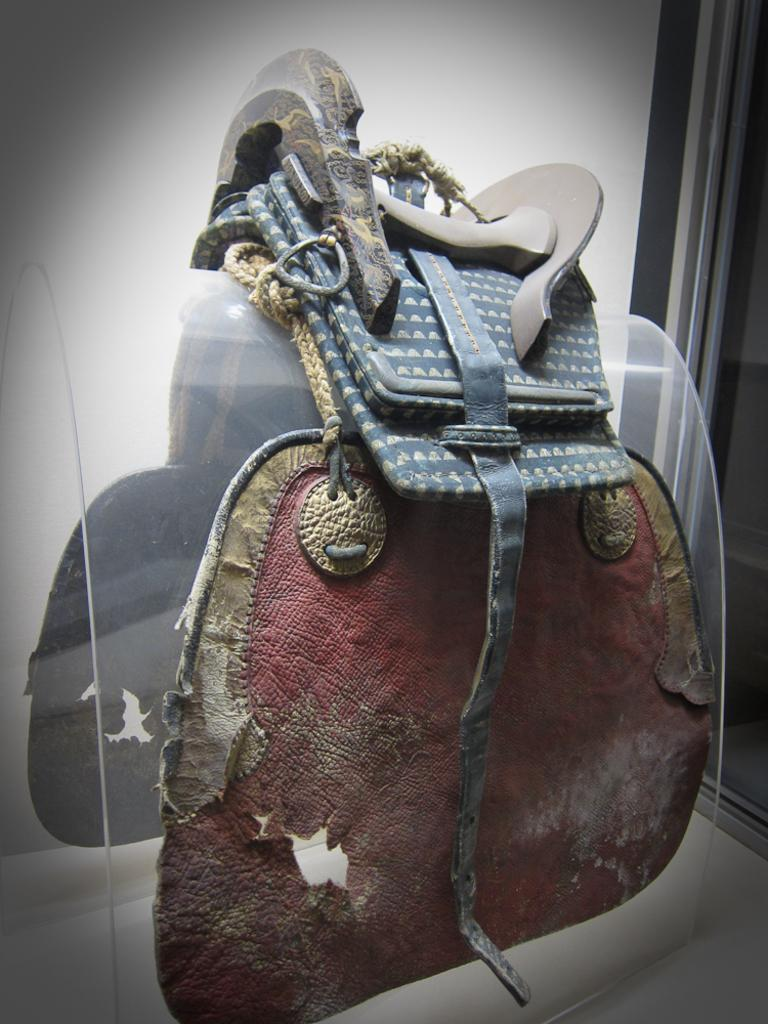What type of carrier is visible in the image? There is a latigo carrier in the image. Where is the latigo carrier placed? The latigo carrier is placed on a horse. What is the purpose of the latigo carrier in the image? The latigo carrier is functioning as a tack on the horse. How many grapes are hanging from the latigo carrier in the image? There are no grapes present in the image; it features a latigo carrier placed on a horse. What type of station does the latigo carrier serve in the image? The image does not depict a station, as it features a latigo carrier placed on a horse. 